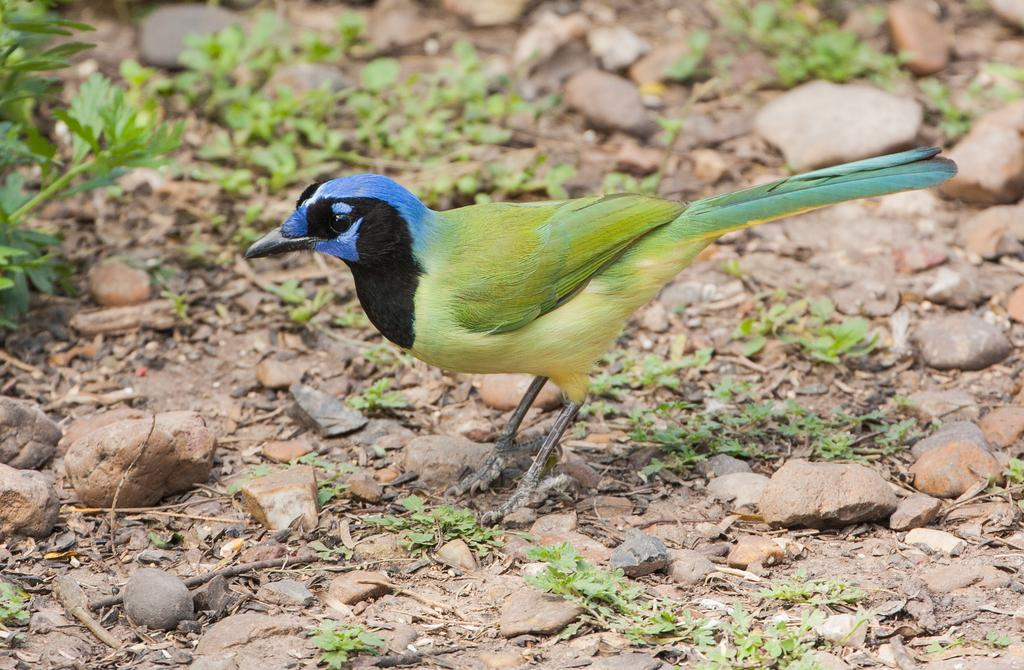What type of animal can be seen in the image? There is a colorful bird in the image. Where is the bird located in the image? The bird is standing on the ground. What other objects can be seen in the image besides the bird? There are stones and plants visible in the image. What color is the scarf that the bird is wearing in the image? There is no scarf present in the image; the bird is not wearing any clothing. 